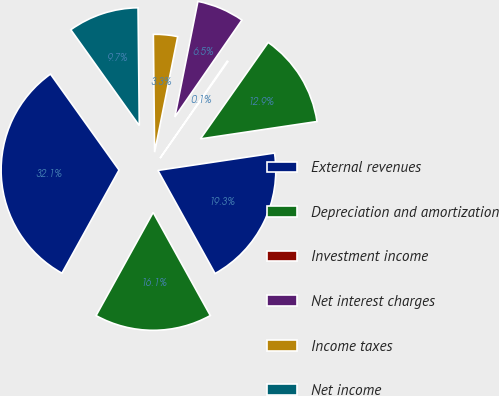Convert chart to OTSL. <chart><loc_0><loc_0><loc_500><loc_500><pie_chart><fcel>External revenues<fcel>Depreciation and amortization<fcel>Investment income<fcel>Net interest charges<fcel>Income taxes<fcel>Net income<fcel>Total assets<fcel>Property additions<nl><fcel>19.3%<fcel>12.9%<fcel>0.11%<fcel>6.5%<fcel>3.31%<fcel>9.7%<fcel>32.09%<fcel>16.1%<nl></chart> 